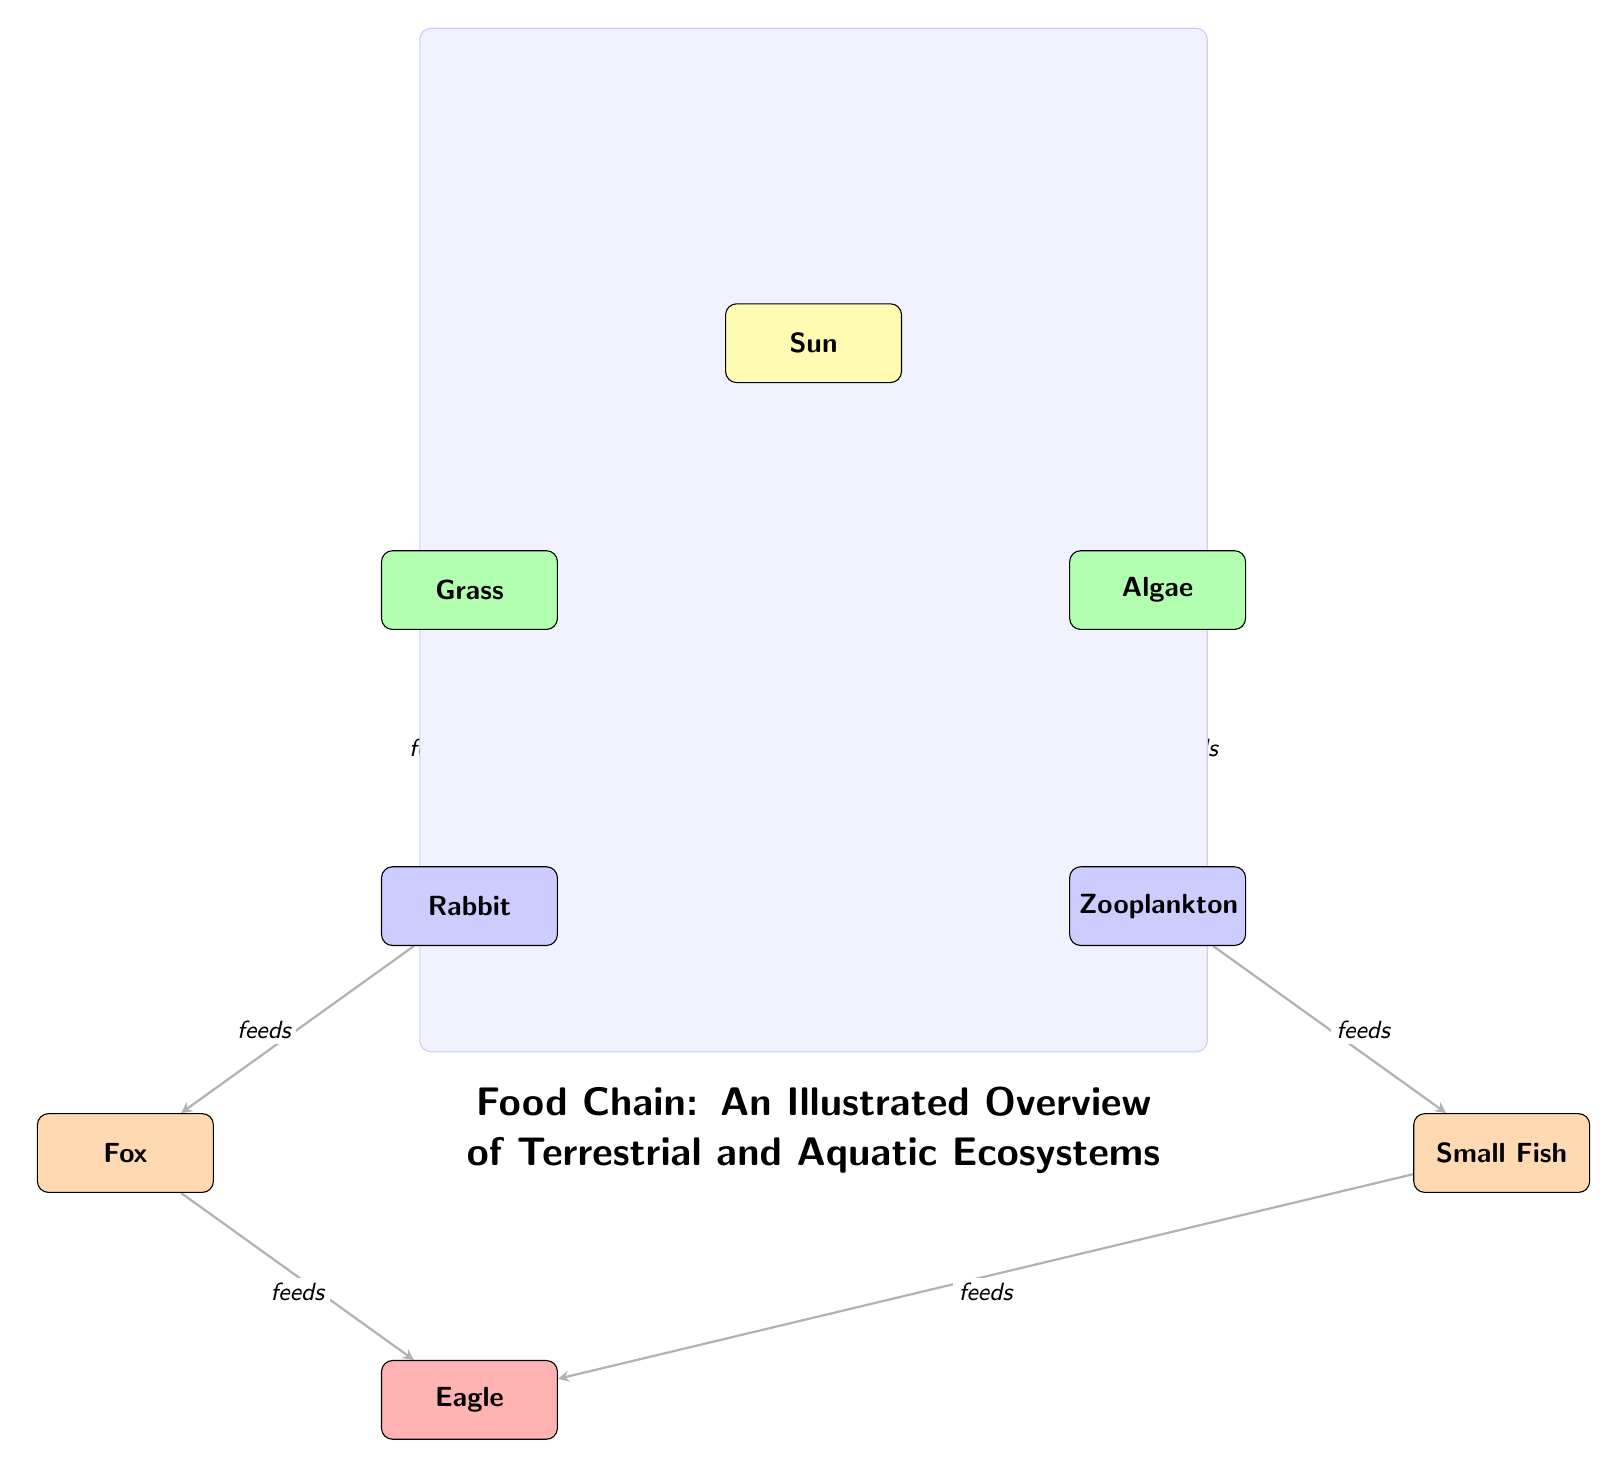What's the first source of energy in this diagram? The diagram identifies the Sun as the first source of energy. It is positioned at the top of the diagram, providing energy to the producers (Grass and Algae) below it.
Answer: Sun How many primary consumers are represented in the diagram? The diagram shows two primary consumers: Rabbit and Zooplankton. They are located beneath each producer, clearly indicating their role in the food chain.
Answer: 2 What do rabbits feed on? The diagram directly shows an arrow pointing from Grass to Rabbit, indicating that Rabbits feed on Grass. This can be confirmed by following the directed edge from Grass to Rabbit.
Answer: Grass Who feeds on zooplankton? The diagram depicts a relationship where Small Fish feeds on Zooplankton, indicated by the arrow that shows the flow of energy from Zooplankton to Small Fish.
Answer: Small Fish How many tertiary consumers are present in the diagram? Observing the diagram, there is one tertiary consumer: Eagle. It is linked with arrows showing that it feeds on both Fox and Small Fish, but is the only one categorized as a tertiary consumer.
Answer: 1 What is the energy flow direction from producers to consumers? The energy flow direction moves from the producers (Grass and Algae) upwards to the primary consumers (Rabbit and Zooplankton), as shown by arrows. This denotes that energy from producers goes to consumers.
Answer: Upwards Which consumer is higher in the food chain: Fox or Rabbit? By interpreting the diagram, Fox is positioned above Rabbit, indicating that Fox is a secondary consumer while Rabbit is a primary consumer, naturally placing Fox higher in the food chain.
Answer: Fox How does the Sun interact with the producers? The diagram illustrates that the Sun provides energy to the producers (Grass and Algae). This interaction is evidenced by the arrows pointing from the Sun to each of the producers, conveying this relationship.
Answer: Provides energy What role does algae play in this ecosystem? Algae acts as a producer in this ecosystem, converting sunlight into energy, which is reflected in its position and the arrow from the Sun depicting energy provision to it, followed by its connection to a primary consumer.
Answer: Producer 